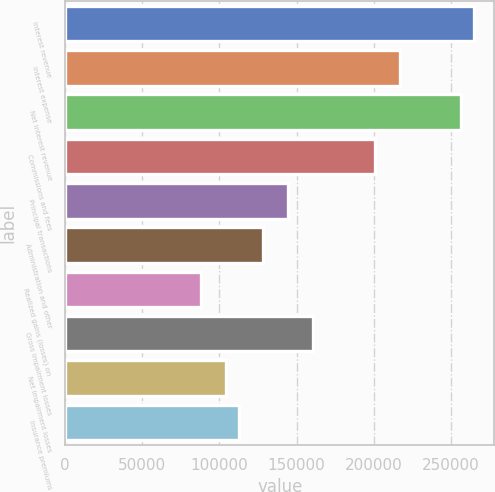Convert chart to OTSL. <chart><loc_0><loc_0><loc_500><loc_500><bar_chart><fcel>Interest revenue<fcel>Interest expense<fcel>Net interest revenue<fcel>Commissions and fees<fcel>Principal transactions<fcel>Administration and other<fcel>Realized gains (losses) on<fcel>Gross impairment losses<fcel>Net impairment losses<fcel>Insurance premiums<nl><fcel>264939<fcel>216768<fcel>256910<fcel>200711<fcel>144512<fcel>128456<fcel>88313.4<fcel>160569<fcel>104370<fcel>112399<nl></chart> 